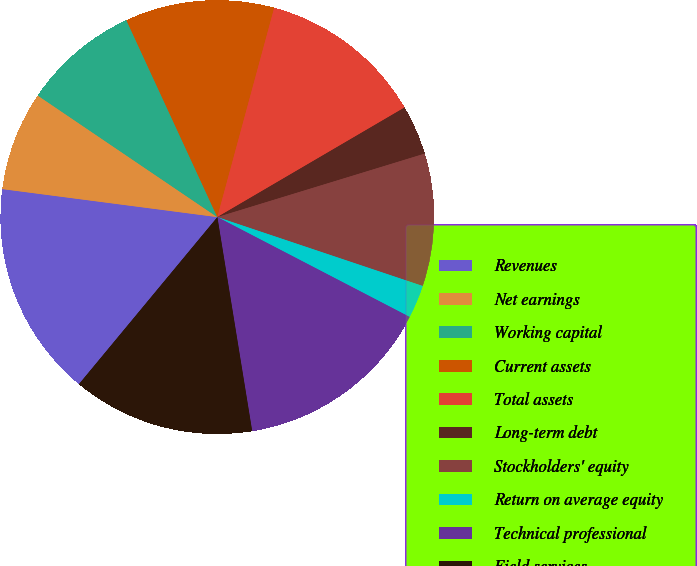Convert chart to OTSL. <chart><loc_0><loc_0><loc_500><loc_500><pie_chart><fcel>Revenues<fcel>Net earnings<fcel>Working capital<fcel>Current assets<fcel>Total assets<fcel>Long-term debt<fcel>Stockholders' equity<fcel>Return on average equity<fcel>Technical professional<fcel>Field services<nl><fcel>16.05%<fcel>7.41%<fcel>8.64%<fcel>11.11%<fcel>12.35%<fcel>3.7%<fcel>9.88%<fcel>2.47%<fcel>14.81%<fcel>13.58%<nl></chart> 